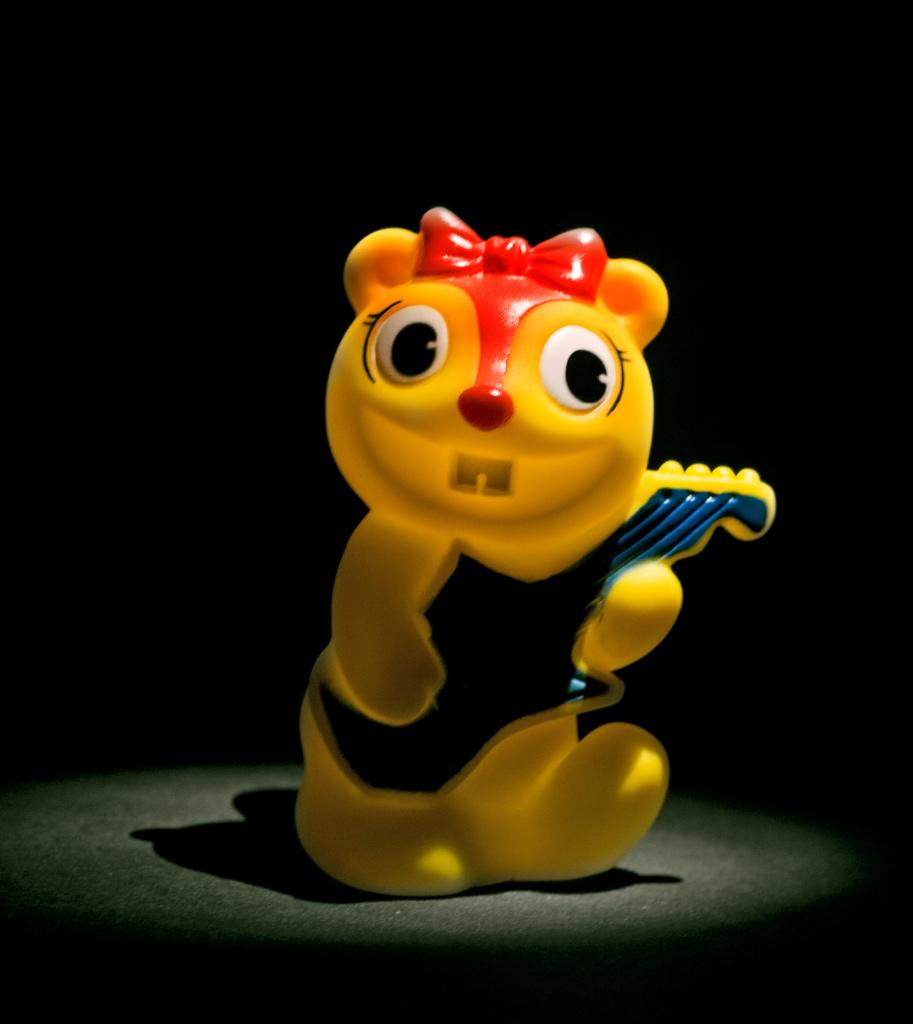What is the main subject in the center of the image? There is a toy in the center of the image. Can you describe the location of the toy in the image? The toy is on a surface in the image. What type of fuel is being used by the toy in the image? There is no indication in the image that the toy requires fuel or any other energy source. 